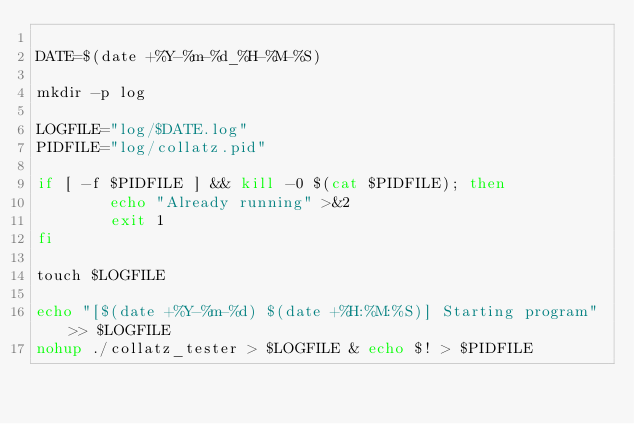Convert code to text. <code><loc_0><loc_0><loc_500><loc_500><_Bash_>
DATE=$(date +%Y-%m-%d_%H-%M-%S)

mkdir -p log

LOGFILE="log/$DATE.log"
PIDFILE="log/collatz.pid"

if [ -f $PIDFILE ] && kill -0 $(cat $PIDFILE); then
        echo "Already running" >&2
        exit 1
fi

touch $LOGFILE

echo "[$(date +%Y-%m-%d) $(date +%H:%M:%S)] Starting program" >> $LOGFILE
nohup ./collatz_tester > $LOGFILE & echo $! > $PIDFILE
</code> 